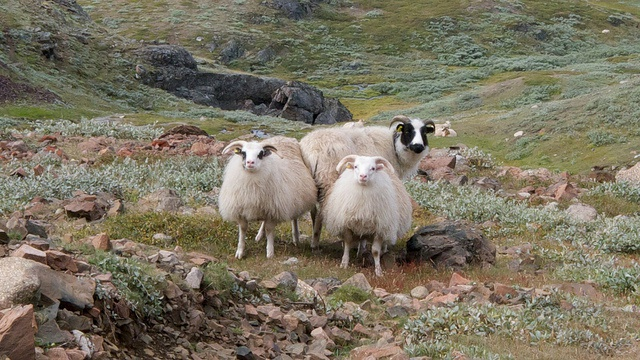Describe the objects in this image and their specific colors. I can see sheep in gray, darkgray, and lightgray tones, sheep in gray, darkgray, and lightgray tones, and sheep in gray, darkgray, and lightgray tones in this image. 